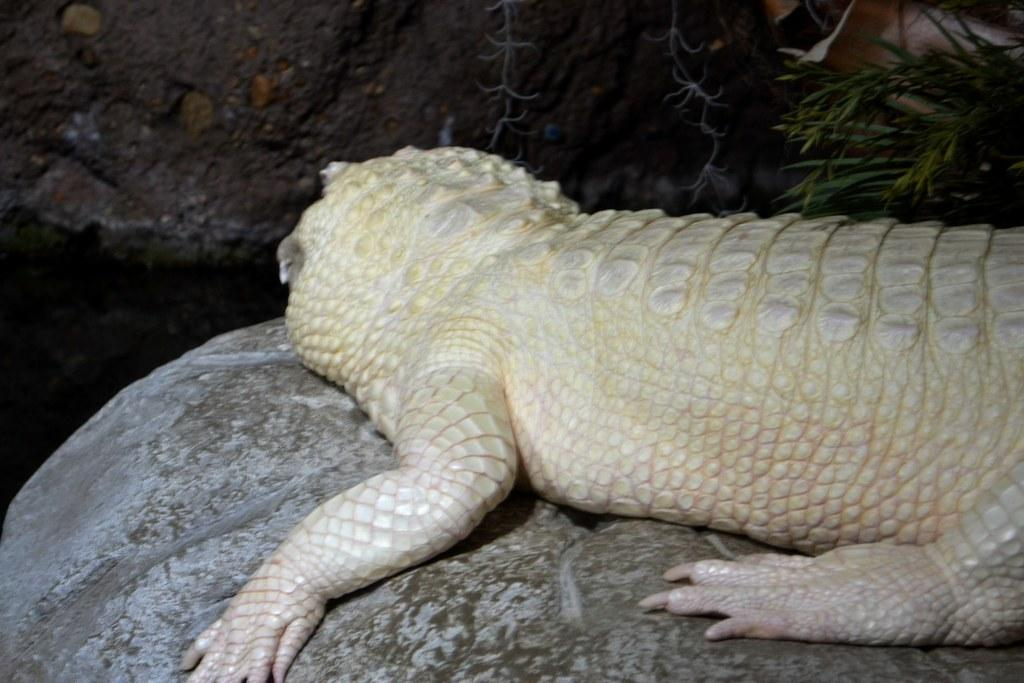What is the main subject of the image? There is an animal on a rock in the image. Can you describe the setting of the image? There is a tree in the background of the image. Where is the book located in the image? There is no book present in the image. What type of throne does the animal sit on in the image? There is no throne in the image; the animal is sitting on a rock. 